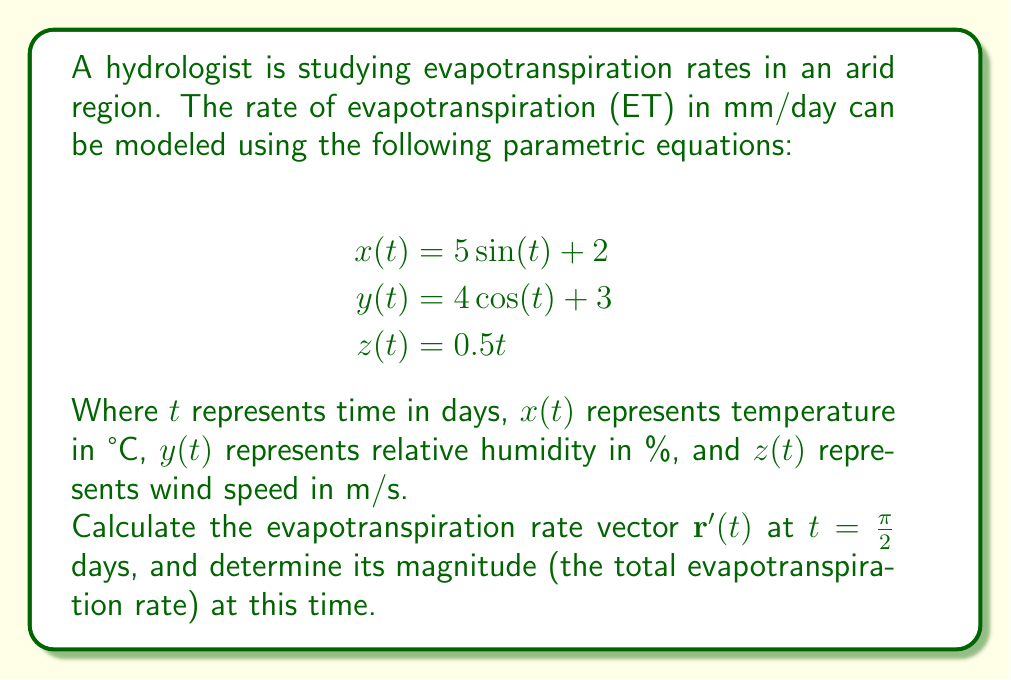Show me your answer to this math problem. To solve this problem, we need to follow these steps:

1) First, we need to find the derivative of each component of the parametric equations:

   $$\begin{align*}
   x'(t) &= 5\cos(t) \\
   y'(t) &= -4\sin(t) \\
   z'(t) &= 0.5
   \end{align*}$$

2) The evapotranspiration rate vector $\mathbf{r}'(t)$ is given by:

   $$\mathbf{r}'(t) = \langle x'(t), y'(t), z'(t) \rangle = \langle 5\cos(t), -4\sin(t), 0.5 \rangle$$

3) Now, we need to evaluate this vector at $t = \frac{\pi}{2}$:

   $$\begin{align*}
   x'(\frac{\pi}{2}) &= 5\cos(\frac{\pi}{2}) = 0 \\
   y'(\frac{\pi}{2}) &= -4\sin(\frac{\pi}{2}) = -4 \\
   z'(\frac{\pi}{2}) &= 0.5
   \end{align*}$$

4) Therefore, $\mathbf{r}'(\frac{\pi}{2}) = \langle 0, -4, 0.5 \rangle$

5) To find the magnitude of this vector (the total evapotranspiration rate), we use the formula:

   $$\|\mathbf{r}'(\frac{\pi}{2})\| = \sqrt{(0)^2 + (-4)^2 + (0.5)^2}$$

6) Simplifying:

   $$\|\mathbf{r}'(\frac{\pi}{2})\| = \sqrt{0 + 16 + 0.25} = \sqrt{16.25} = 4.03$$

Therefore, the total evapotranspiration rate at $t = \frac{\pi}{2}$ days is approximately 4.03 mm/day.
Answer: The evapotranspiration rate vector at $t = \frac{\pi}{2}$ days is $\mathbf{r}'(\frac{\pi}{2}) = \langle 0, -4, 0.5 \rangle$ mm/day, and its magnitude (the total evapotranspiration rate) is approximately 4.03 mm/day. 